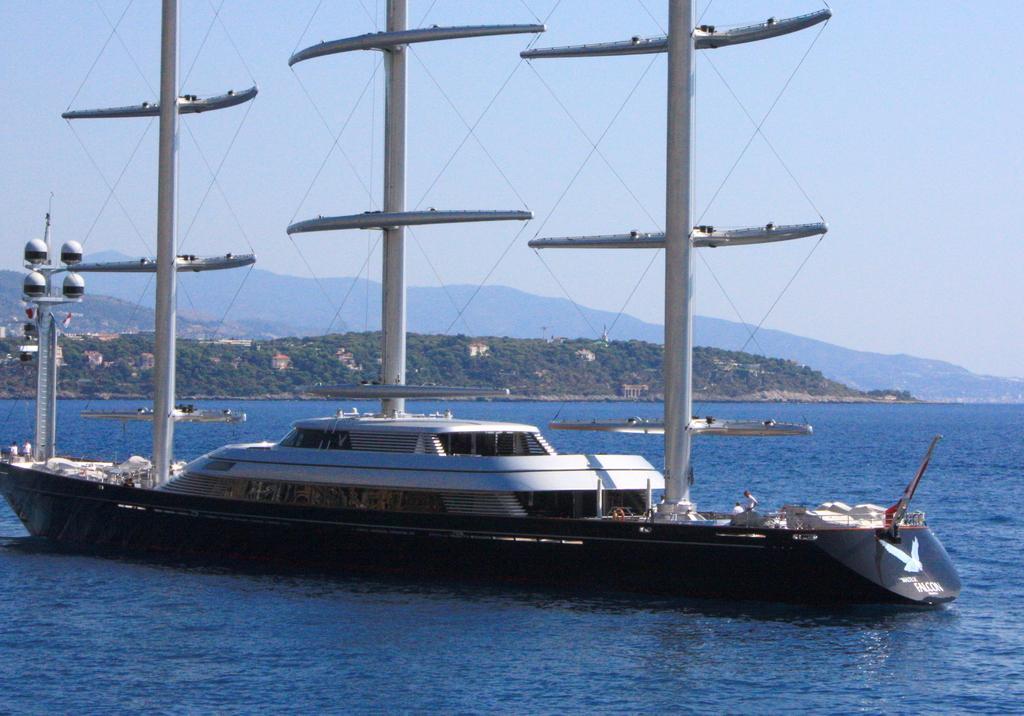In one or two sentences, can you explain what this image depicts? As we can see in the image there is water, boats, trees, houses, hills and sky. 